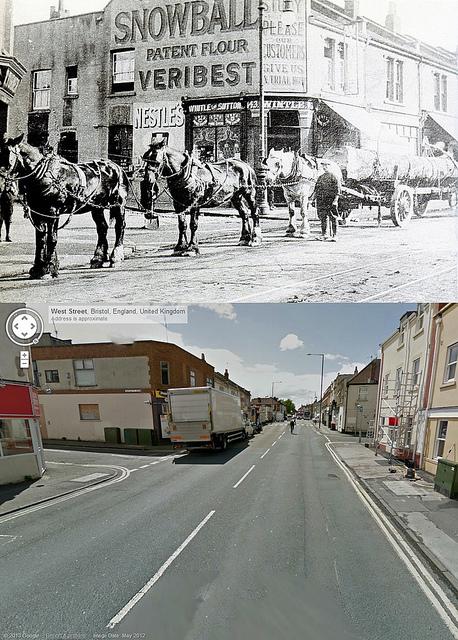What animals are shown in the picture on top?
Be succinct. Horses. How many cars are there?
Write a very short answer. 0. Is this from Google Earth?
Concise answer only. Yes. 